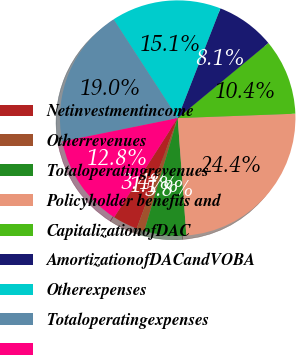Convert chart to OTSL. <chart><loc_0><loc_0><loc_500><loc_500><pie_chart><fcel>Netinvestmentincome<fcel>Otherrevenues<fcel>Totaloperatingrevenues<fcel>Policyholder benefits and<fcel>CapitalizationofDAC<fcel>AmortizationofDACandVOBA<fcel>Otherexpenses<fcel>Totaloperatingexpenses<fcel>Unnamed: 8<nl><fcel>3.41%<fcel>1.08%<fcel>5.75%<fcel>24.42%<fcel>10.41%<fcel>8.08%<fcel>15.08%<fcel>19.01%<fcel>12.75%<nl></chart> 